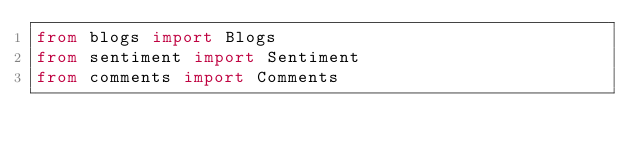<code> <loc_0><loc_0><loc_500><loc_500><_Python_>from blogs import Blogs
from sentiment import Sentiment
from comments import Comments
</code> 